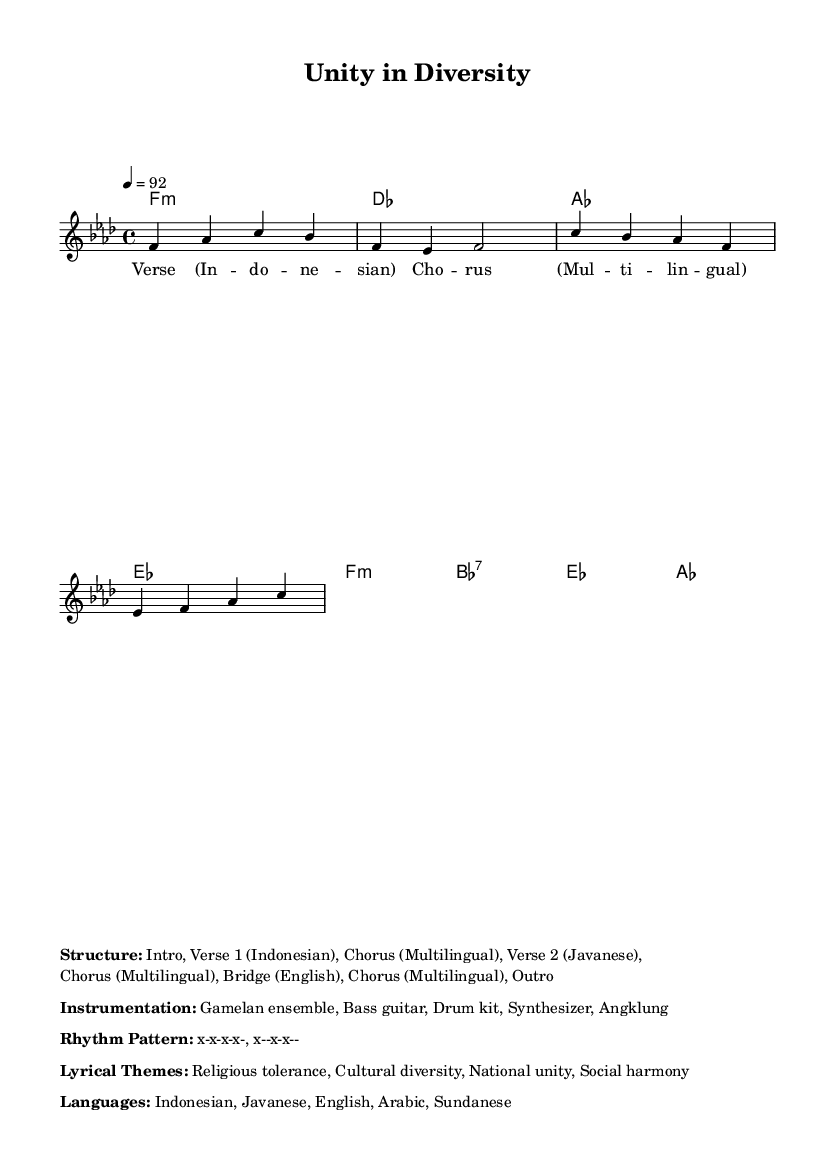What is the key signature of this music? The key signature includes flats which indicate that the music is in F minor. F minor has four flats: B♭, E♭, A♭, and D♭.
Answer: F minor What is the time signature of the piece? The time signature shown in the music indicates that there are four beats in each measure, which is represented by 4/4.
Answer: 4/4 What is the tempo marking for this piece? The tempo marking indicates the speed at which the music should be played. In this case, it is 92 beats per minute, meaning the quarter note gets one beat and the tempo is moderate.
Answer: 92 How many verses are there in the structure of the song? The structure indicates there are two verses mentioned: Verse 1 in Indonesian and Verse 2 in Javanese, separated by choruses and a bridge.
Answer: Two What are the lyrical themes of this rap fusion? The lyrical themes focus on social issues relevant to the cultural diversity of Indonesia, particularly emphasizing religious tolerance, cultural diversity, national unity, and social harmony.
Answer: Religious tolerance, cultural diversity, national unity, social harmony Which instruments are featured in the instrumentation? The instrumentation lists the following instruments: Gamelan ensemble, Bass guitar, Drum kit, Synthesizer, and Angklung, showcasing the fusion of traditional and contemporary sounds.
Answer: Gamelan ensemble, Bass guitar, Drum kit, Synthesizer, Angklung In which languages does the rap incorporate lyrics? The rap incorporates lyrics in multiple languages: Indonesian, Javanese, English, Arabic, and Sundanese, reflecting Indonesia's rich linguistic diversity.
Answer: Indonesian, Javanese, English, Arabic, Sundanese 